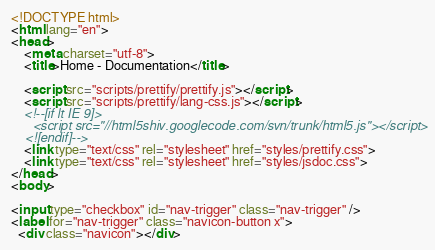Convert code to text. <code><loc_0><loc_0><loc_500><loc_500><_HTML_><!DOCTYPE html>
<html lang="en">
<head>
    <meta charset="utf-8">
    <title>Home - Documentation</title>

    <script src="scripts/prettify/prettify.js"></script>
    <script src="scripts/prettify/lang-css.js"></script>
    <!--[if lt IE 9]>
      <script src="//html5shiv.googlecode.com/svn/trunk/html5.js"></script>
    <![endif]-->
    <link type="text/css" rel="stylesheet" href="styles/prettify.css">
    <link type="text/css" rel="stylesheet" href="styles/jsdoc.css">
</head>
<body>

<input type="checkbox" id="nav-trigger" class="nav-trigger" />
<label for="nav-trigger" class="navicon-button x">
  <div class="navicon"></div></code> 